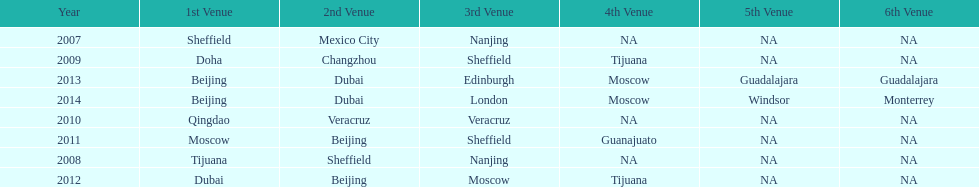What was the last year where tijuana was a venue? 2012. 